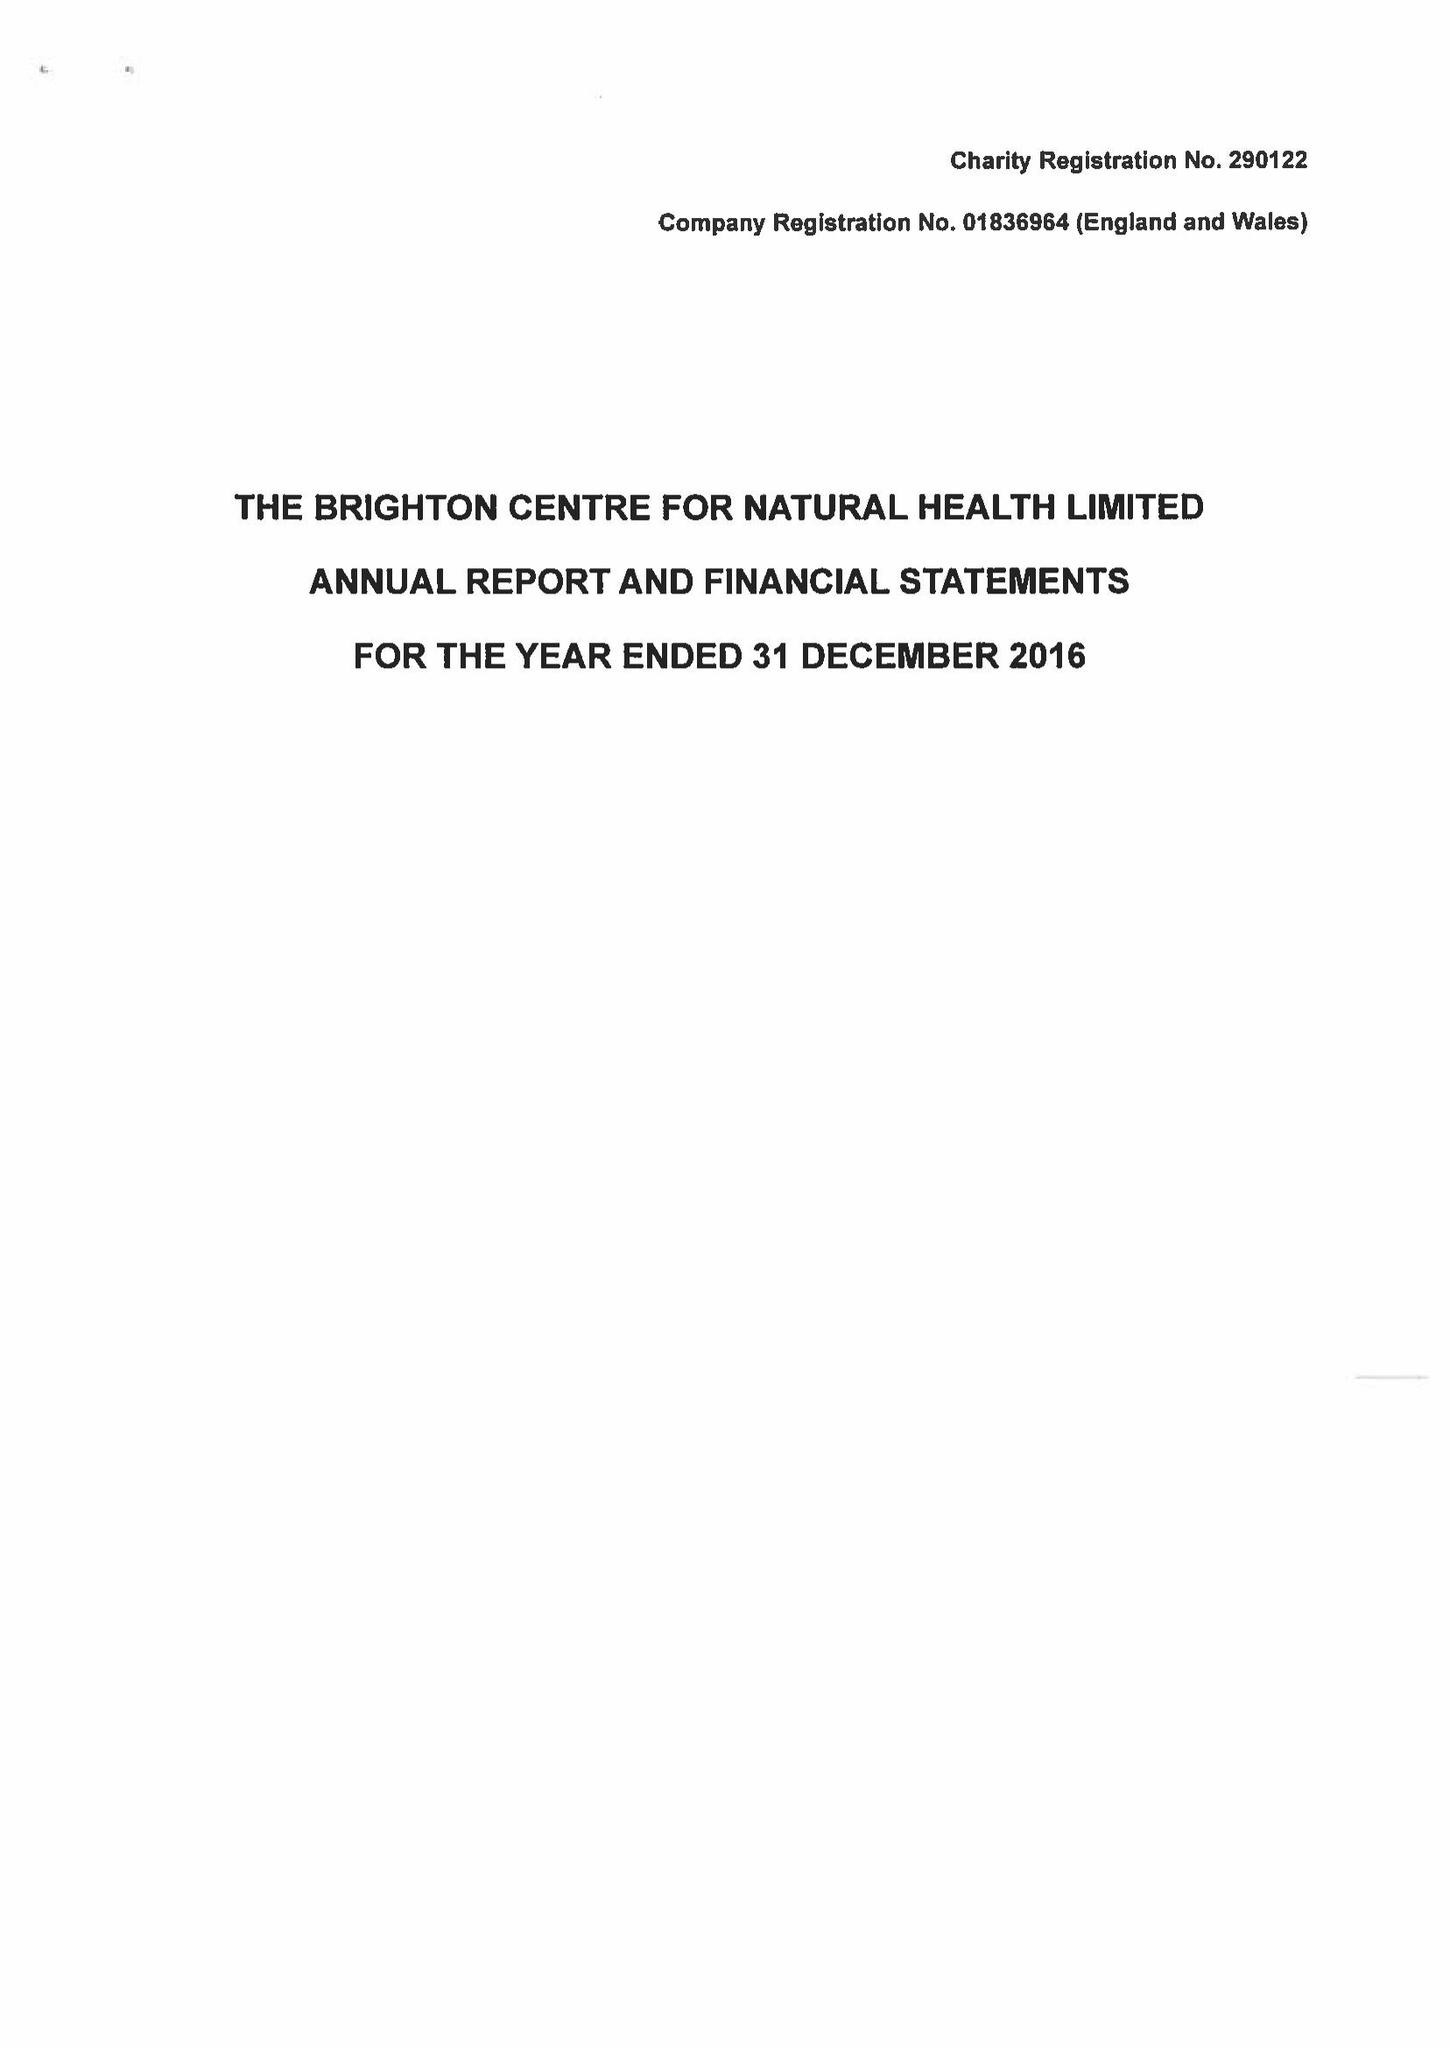What is the value for the address__street_line?
Answer the question using a single word or phrase. 27 REGENT STREET 